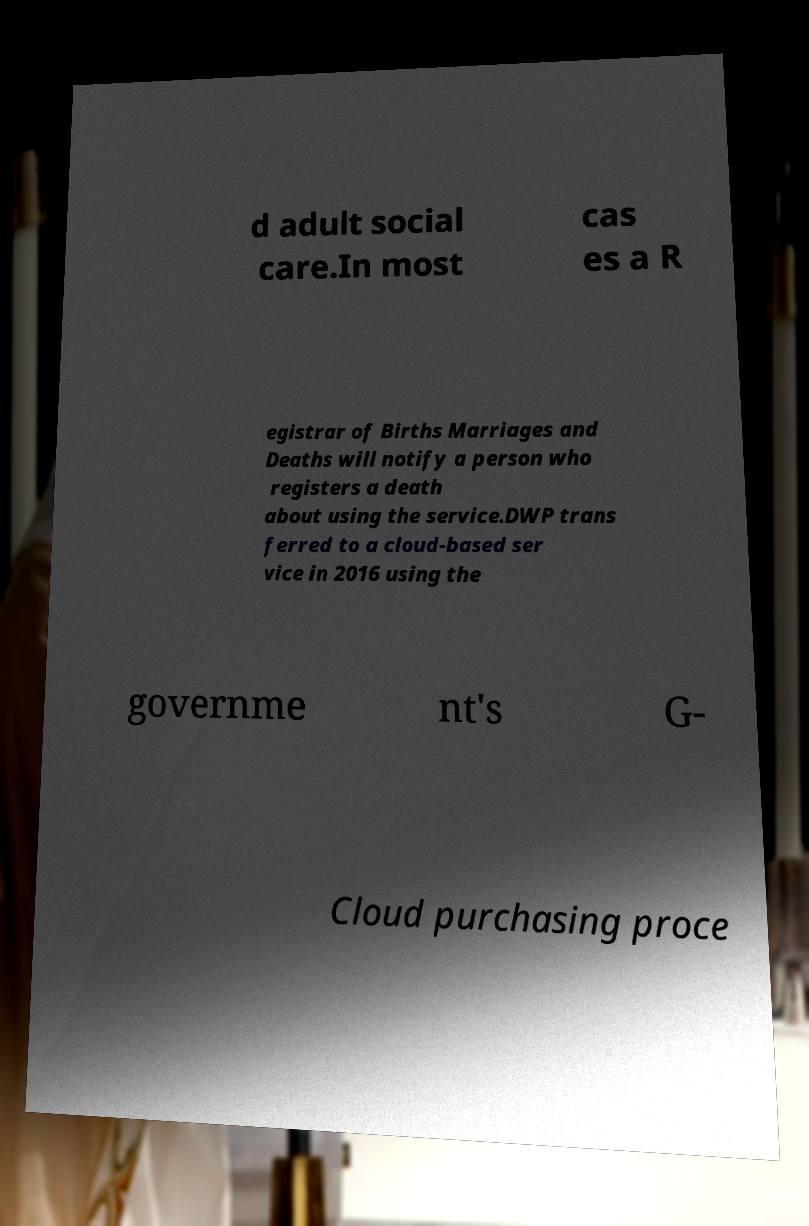Can you accurately transcribe the text from the provided image for me? d adult social care.In most cas es a R egistrar of Births Marriages and Deaths will notify a person who registers a death about using the service.DWP trans ferred to a cloud-based ser vice in 2016 using the governme nt's G- Cloud purchasing proce 